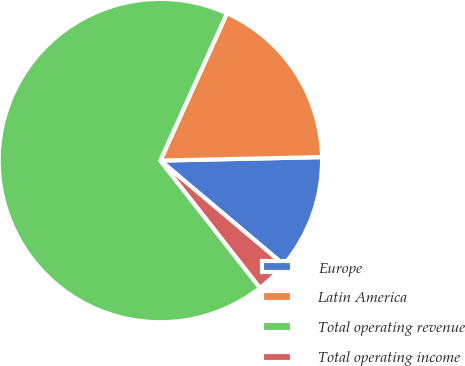Convert chart to OTSL. <chart><loc_0><loc_0><loc_500><loc_500><pie_chart><fcel>Europe<fcel>Latin America<fcel>Total operating revenue<fcel>Total operating income<nl><fcel>11.49%<fcel>17.9%<fcel>67.32%<fcel>3.28%<nl></chart> 